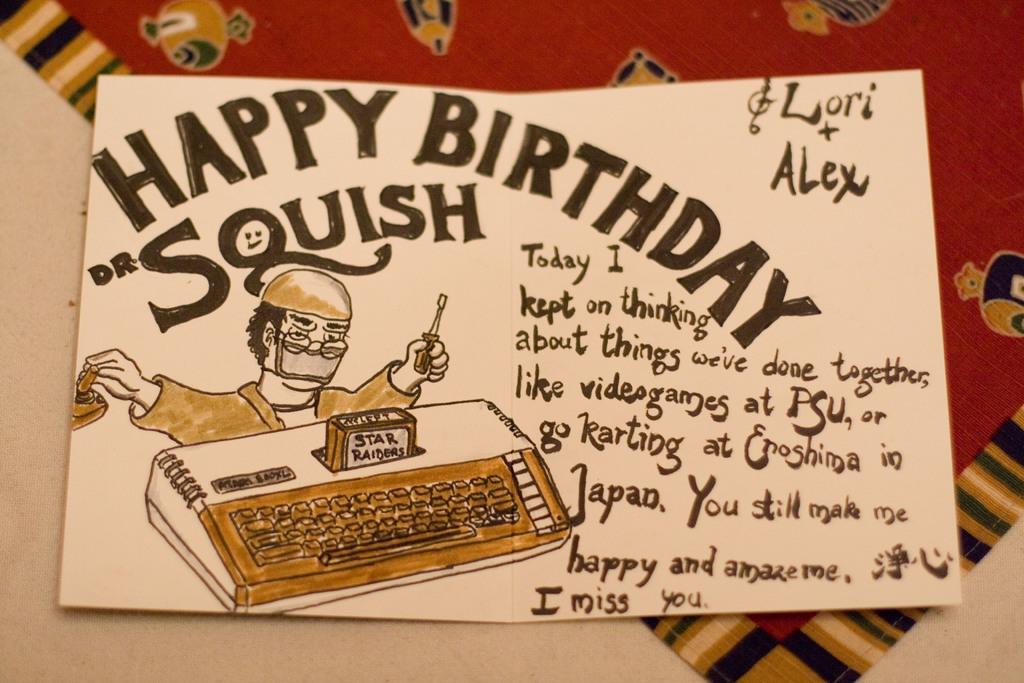What type of card is this?
Your answer should be very brief. Birthday. What is the dr's name?
Ensure brevity in your answer.  Squish. 